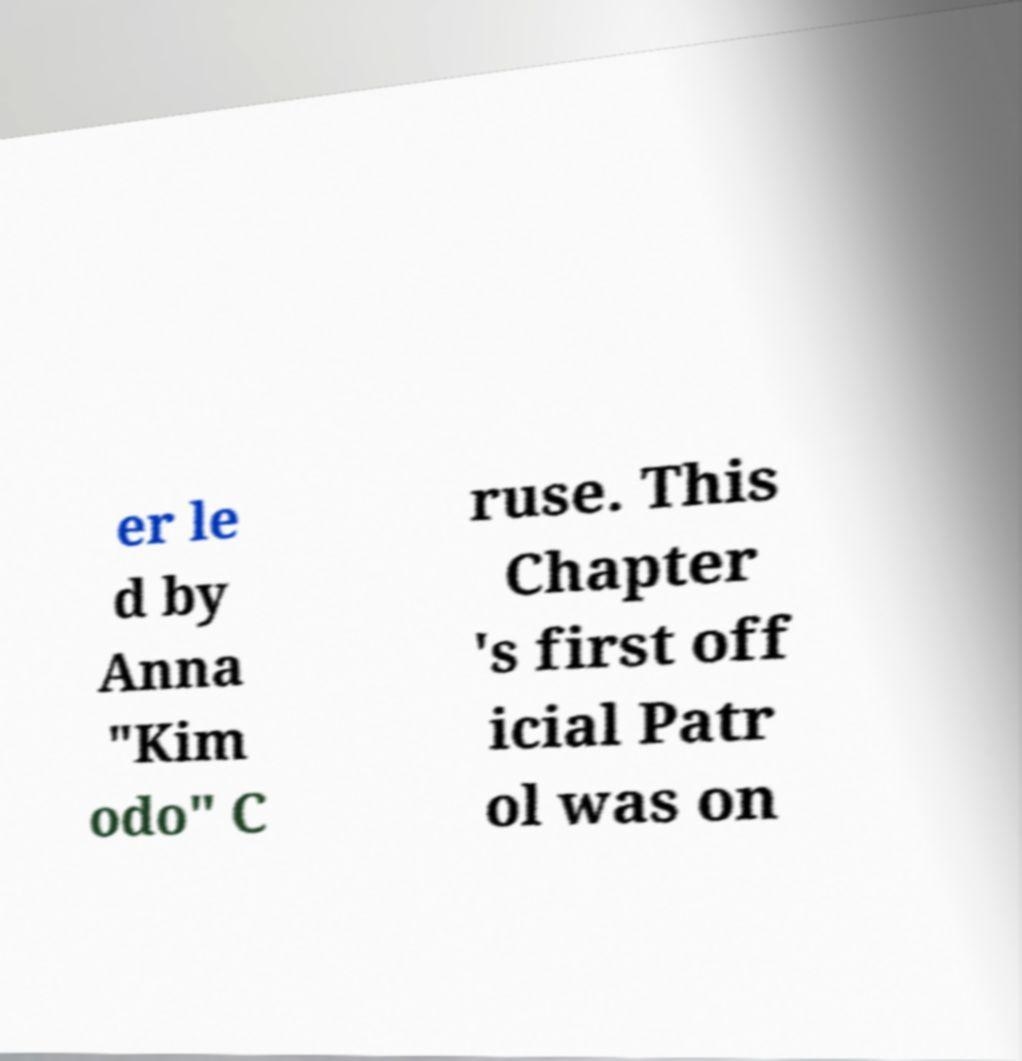What messages or text are displayed in this image? I need them in a readable, typed format. er le d by Anna "Kim odo" C ruse. This Chapter 's first off icial Patr ol was on 